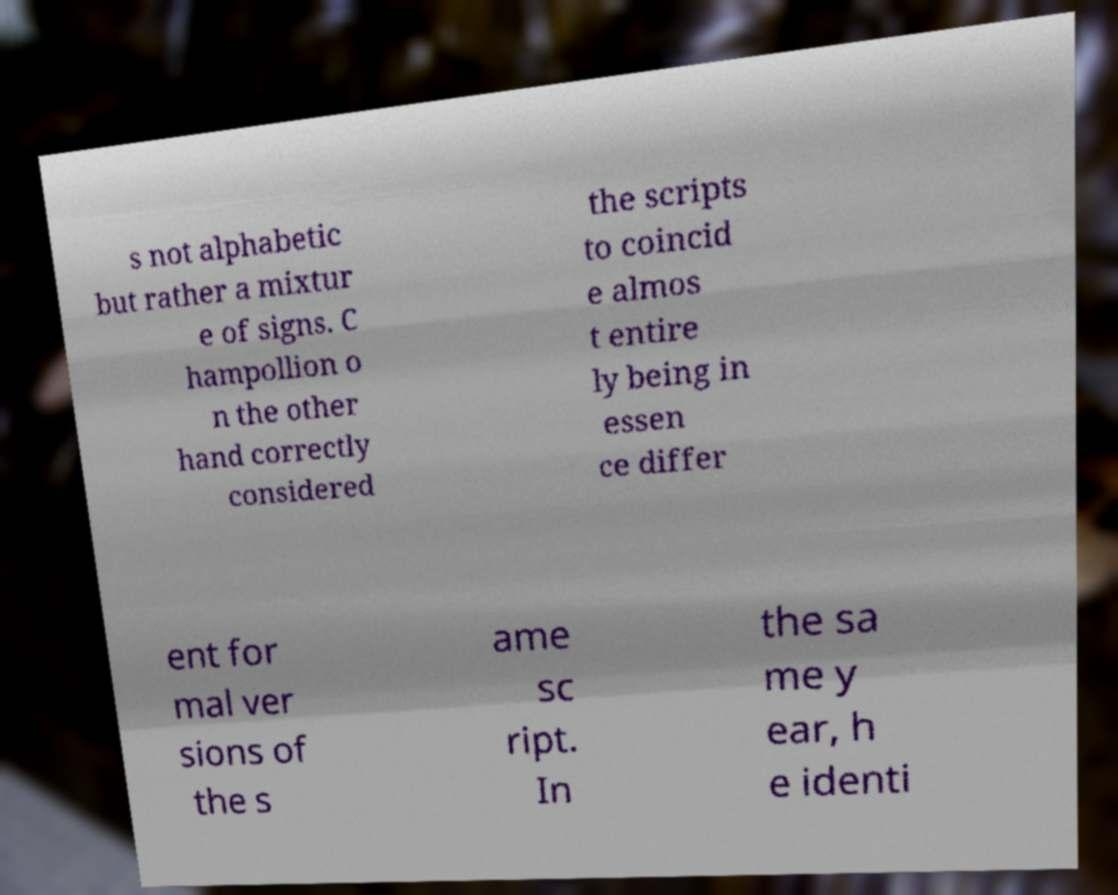Please read and relay the text visible in this image. What does it say? s not alphabetic but rather a mixtur e of signs. C hampollion o n the other hand correctly considered the scripts to coincid e almos t entire ly being in essen ce differ ent for mal ver sions of the s ame sc ript. In the sa me y ear, h e identi 